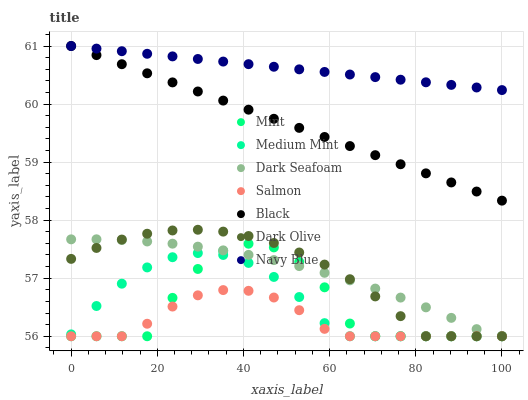Does Salmon have the minimum area under the curve?
Answer yes or no. Yes. Does Navy Blue have the maximum area under the curve?
Answer yes or no. Yes. Does Dark Olive have the minimum area under the curve?
Answer yes or no. No. Does Dark Olive have the maximum area under the curve?
Answer yes or no. No. Is Navy Blue the smoothest?
Answer yes or no. Yes. Is Mint the roughest?
Answer yes or no. Yes. Is Dark Olive the smoothest?
Answer yes or no. No. Is Dark Olive the roughest?
Answer yes or no. No. Does Medium Mint have the lowest value?
Answer yes or no. Yes. Does Navy Blue have the lowest value?
Answer yes or no. No. Does Black have the highest value?
Answer yes or no. Yes. Does Dark Olive have the highest value?
Answer yes or no. No. Is Mint less than Navy Blue?
Answer yes or no. Yes. Is Navy Blue greater than Medium Mint?
Answer yes or no. Yes. Does Dark Seafoam intersect Medium Mint?
Answer yes or no. Yes. Is Dark Seafoam less than Medium Mint?
Answer yes or no. No. Is Dark Seafoam greater than Medium Mint?
Answer yes or no. No. Does Mint intersect Navy Blue?
Answer yes or no. No. 